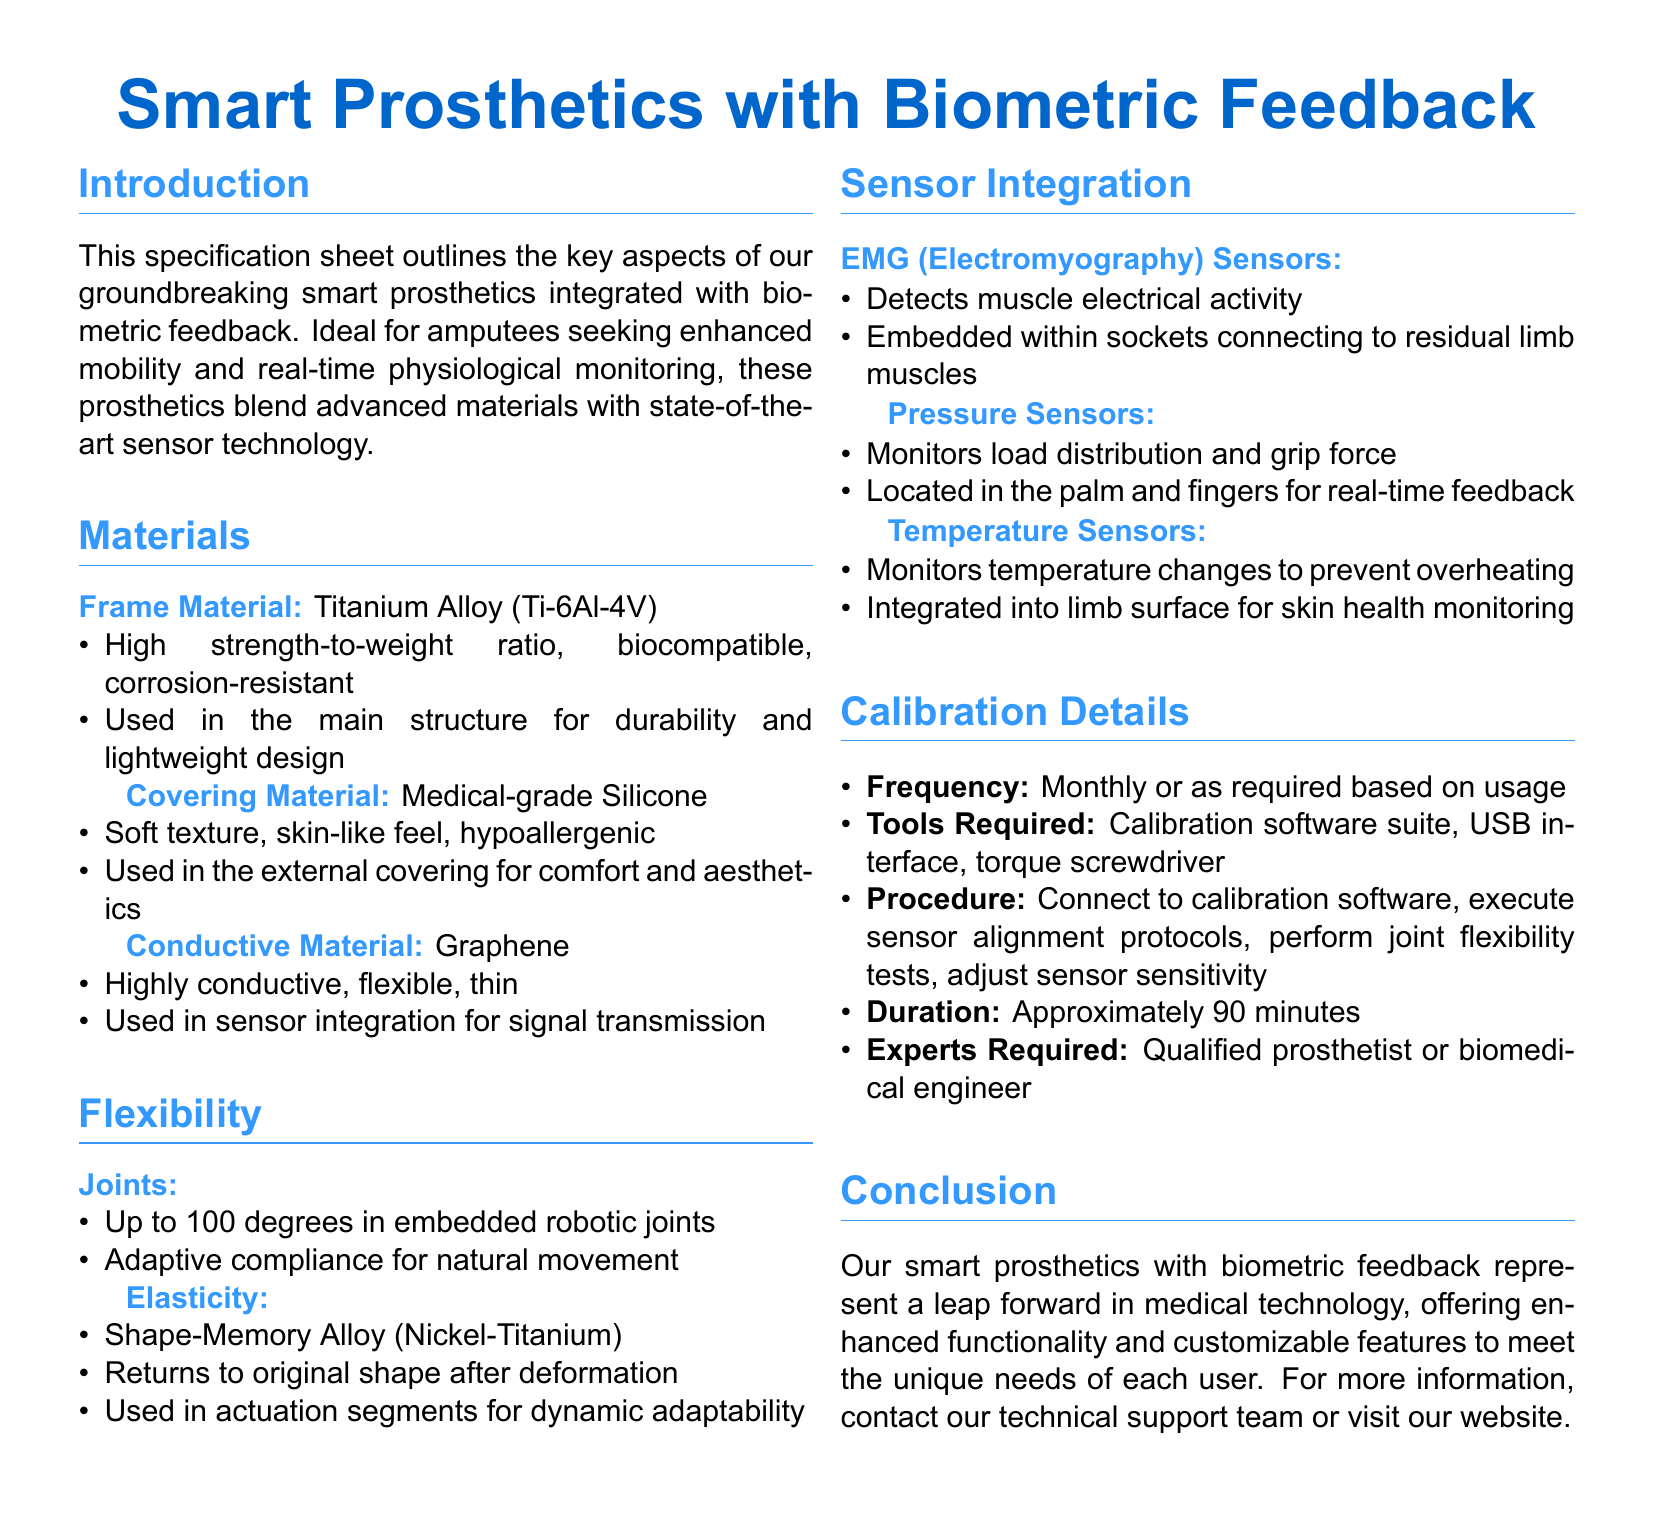What is the frame material used in the prosthetics? The frame material is listed in the materials section and is Titanium Alloy (Ti-6Al-4V).
Answer: Titanium Alloy (Ti-6Al-4V) What type of sensors detects muscle electrical activity? The type of sensors is specified under Sensor Integration, which are EMG (Electromyography) Sensors.
Answer: EMG (Electromyography) Sensors How much can the robotic joints flex? The flexibility detail mentions that the robotic joints can flex up to 100 degrees.
Answer: 100 degrees What is the frequency of calibration for the prosthetics? The calibration frequency is stated in the calibration details as monthly or as required based on usage.
Answer: Monthly or as required What material is used for sensor integration? The material used for sensor integration is graphene as indicated in the materials section.
Answer: Graphene What is the duration of the calibration procedure? The duration is specified in the calibration details, which states approximately 90 minutes.
Answer: Approximately 90 minutes Who is the expert required for calibration? The experts required for calibration are mentioned as a qualified prosthetist or biomedical engineer.
Answer: Qualified prosthetist or biomedical engineer What type of sensors monitors temperature changes? The sensors that monitor temperature changes are specified as Temperature Sensors in the document.
Answer: Temperature Sensors What is the covering material for the prosthetics? The covering material is identified in the materials section and is Medical-grade Silicone.
Answer: Medical-grade Silicone 